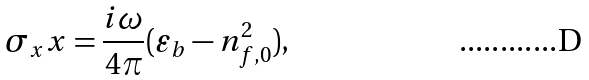<formula> <loc_0><loc_0><loc_500><loc_500>\sigma _ { x } x = \frac { i \omega } { 4 \pi } ( \varepsilon _ { b } - n _ { f , 0 } ^ { 2 } ) ,</formula> 